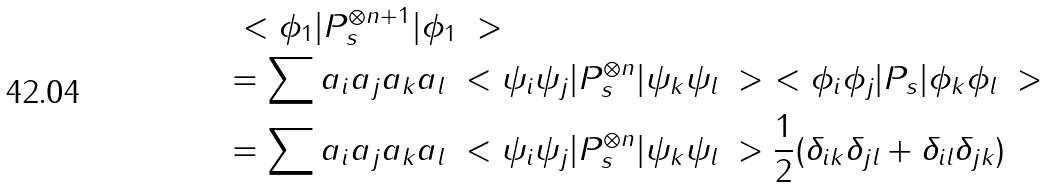<formula> <loc_0><loc_0><loc_500><loc_500>& \ < \phi _ { 1 } | P _ { s } ^ { \otimes n + 1 } | \phi _ { 1 } \ > \\ & = \sum a _ { i } a _ { j } a _ { k } a _ { l } \ < \psi _ { i } \psi _ { j } | P _ { s } ^ { \otimes n } | \psi _ { k } \psi _ { l } \ > \ < \phi _ { i } \phi _ { j } | P _ { s } | \phi _ { k } \phi _ { l } \ > \\ & = \sum a _ { i } a _ { j } a _ { k } a _ { l } \ < \psi _ { i } \psi _ { j } | P _ { s } ^ { \otimes n } | \psi _ { k } \psi _ { l } \ > \frac { 1 } { 2 } ( \delta _ { i k } \delta _ { j l } + \delta _ { i l } \delta _ { j k } )</formula> 